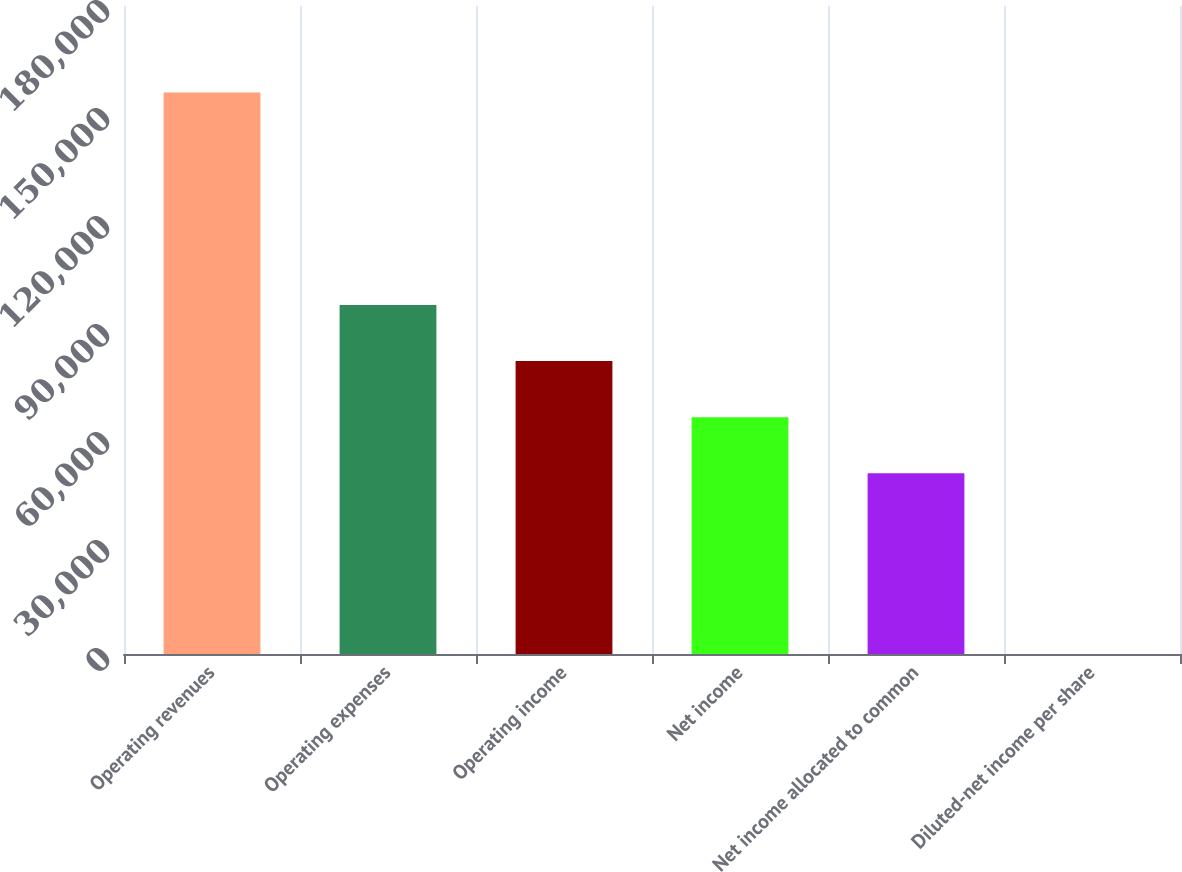<chart> <loc_0><loc_0><loc_500><loc_500><bar_chart><fcel>Operating revenues<fcel>Operating expenses<fcel>Operating income<fcel>Net income<fcel>Net income allocated to common<fcel>Diluted-net income per share<nl><fcel>155946<fcel>96964.6<fcel>81370.1<fcel>65775.5<fcel>50181<fcel>0.61<nl></chart> 